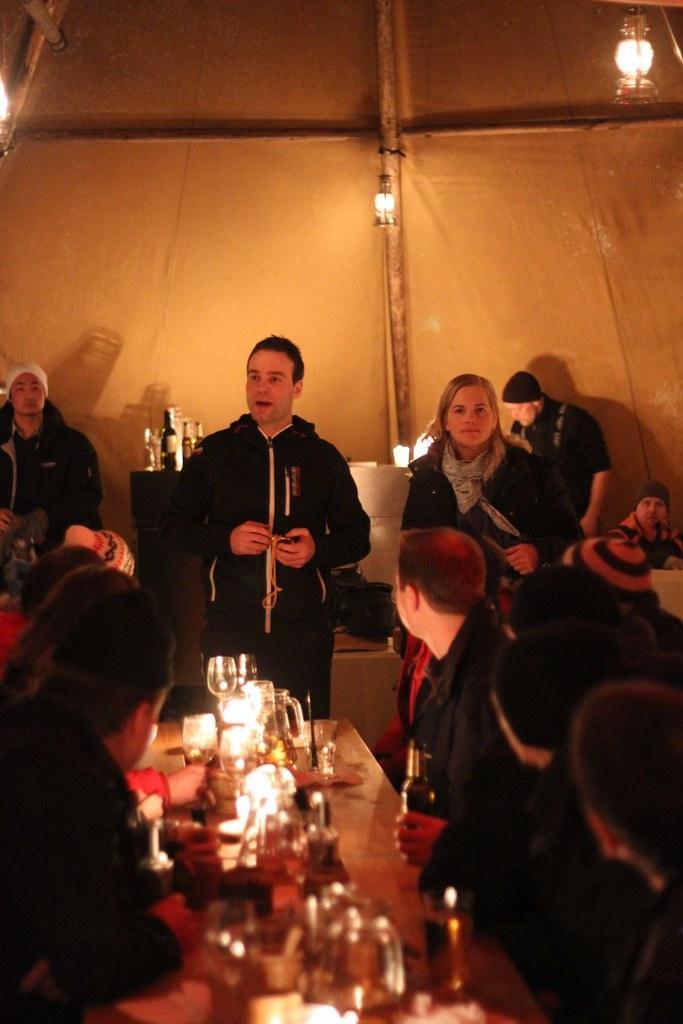In one or two sentences, can you explain what this image depicts? In the image we can see there are many people around and wearing clothes. This is a table, on the table there is a light, wine glass and a bottle. This is a wooden pole. 